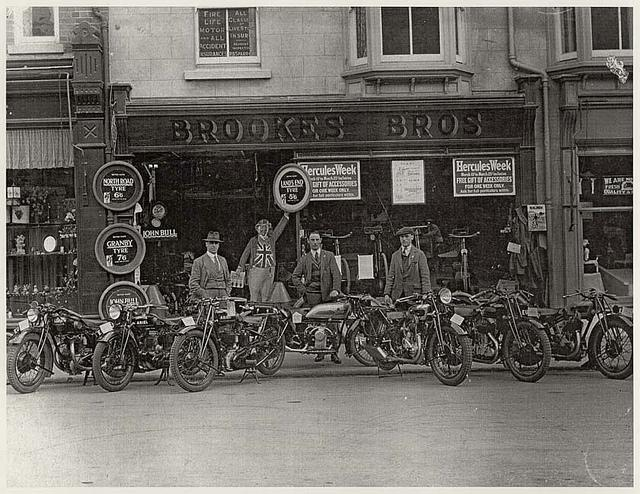What countries flag can be seen on the man's shirt? united kingdom 